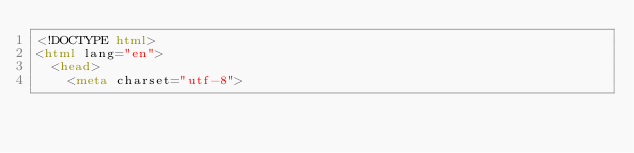Convert code to text. <code><loc_0><loc_0><loc_500><loc_500><_HTML_><!DOCTYPE html>
<html lang="en">
  <head>
    <meta charset="utf-8"></code> 